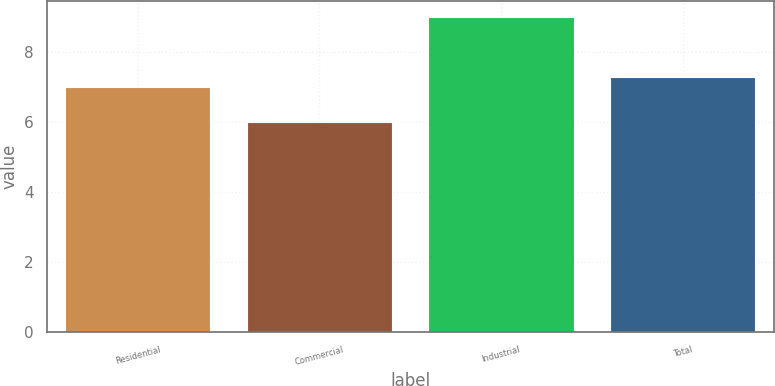<chart> <loc_0><loc_0><loc_500><loc_500><bar_chart><fcel>Residential<fcel>Commercial<fcel>Industrial<fcel>Total<nl><fcel>7<fcel>6<fcel>9<fcel>7.3<nl></chart> 